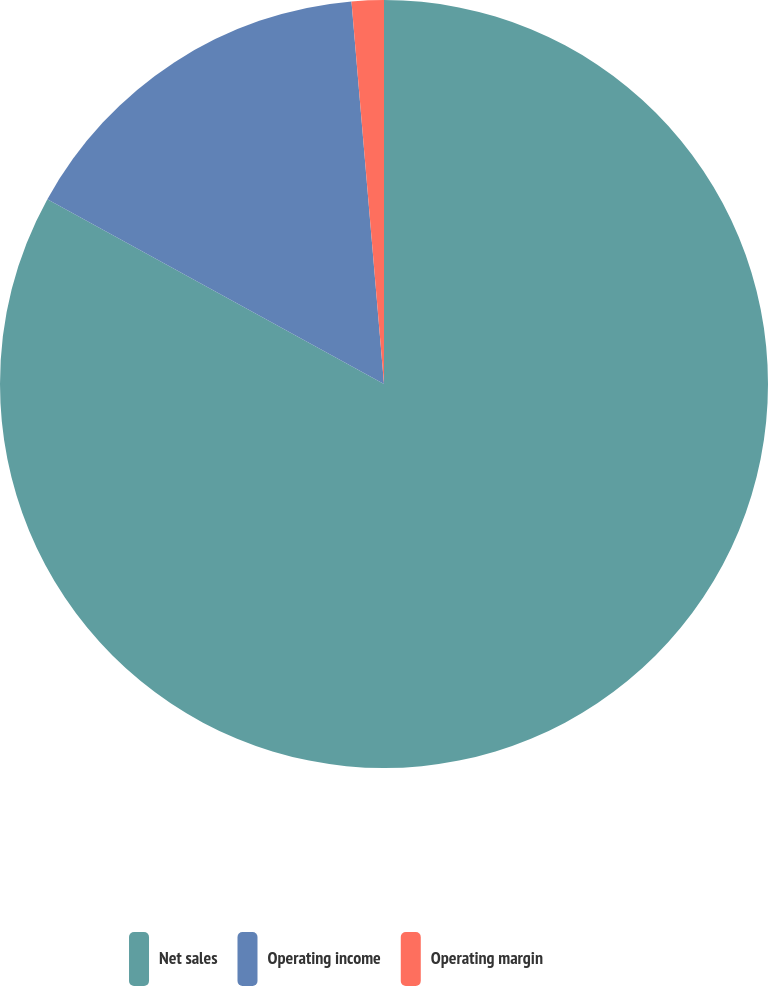<chart> <loc_0><loc_0><loc_500><loc_500><pie_chart><fcel>Net sales<fcel>Operating income<fcel>Operating margin<nl><fcel>82.99%<fcel>15.66%<fcel>1.35%<nl></chart> 